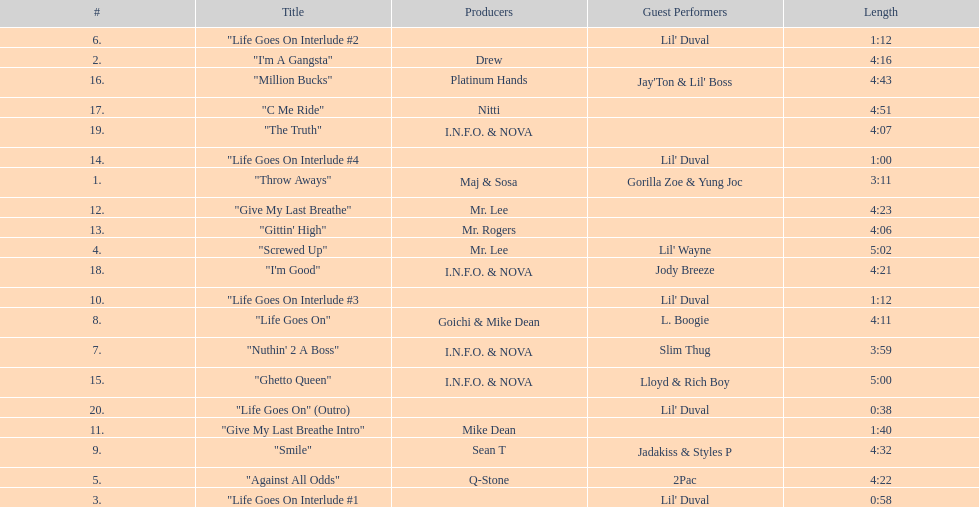Which producers produced the majority of songs on this record? I.N.F.O. & NOVA. 